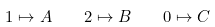<formula> <loc_0><loc_0><loc_500><loc_500>1 \mapsto A \quad 2 \mapsto B \quad 0 \mapsto C</formula> 